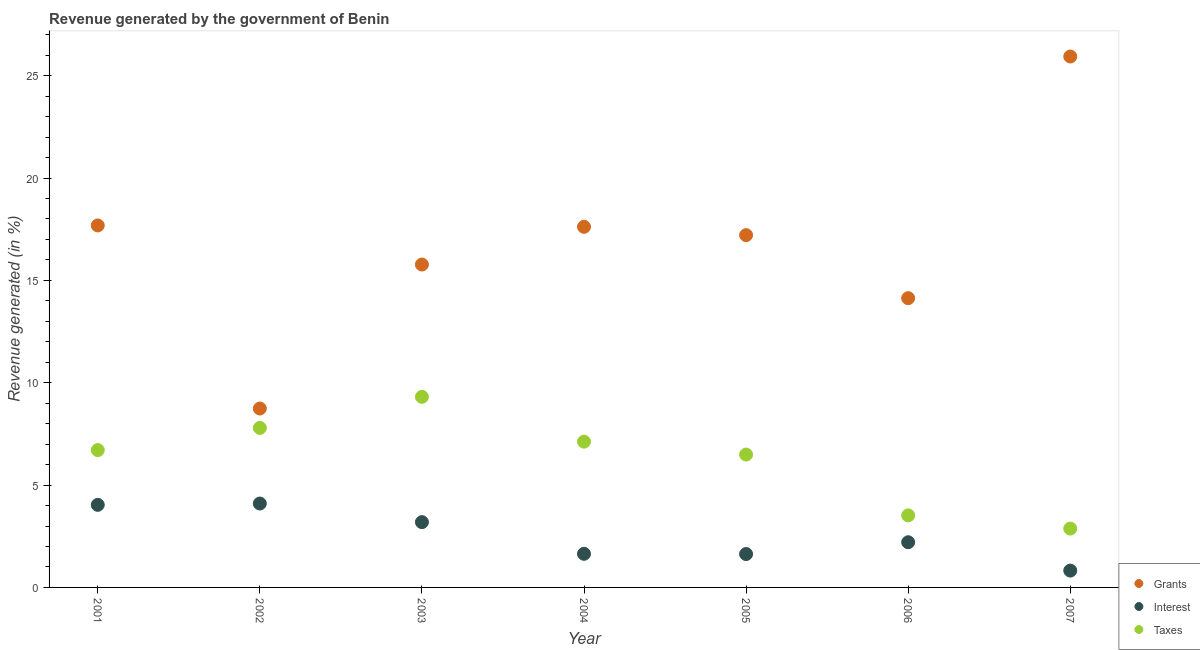How many different coloured dotlines are there?
Make the answer very short. 3. What is the percentage of revenue generated by taxes in 2003?
Ensure brevity in your answer.  9.31. Across all years, what is the maximum percentage of revenue generated by grants?
Offer a very short reply. 25.94. Across all years, what is the minimum percentage of revenue generated by interest?
Provide a succinct answer. 0.82. In which year was the percentage of revenue generated by grants maximum?
Your answer should be compact. 2007. In which year was the percentage of revenue generated by grants minimum?
Provide a succinct answer. 2002. What is the total percentage of revenue generated by taxes in the graph?
Ensure brevity in your answer.  43.82. What is the difference between the percentage of revenue generated by grants in 2002 and that in 2004?
Keep it short and to the point. -8.88. What is the difference between the percentage of revenue generated by taxes in 2004 and the percentage of revenue generated by interest in 2005?
Offer a very short reply. 5.49. What is the average percentage of revenue generated by taxes per year?
Keep it short and to the point. 6.26. In the year 2004, what is the difference between the percentage of revenue generated by taxes and percentage of revenue generated by grants?
Give a very brief answer. -10.5. What is the ratio of the percentage of revenue generated by taxes in 2001 to that in 2005?
Keep it short and to the point. 1.03. Is the difference between the percentage of revenue generated by interest in 2001 and 2006 greater than the difference between the percentage of revenue generated by taxes in 2001 and 2006?
Offer a very short reply. No. What is the difference between the highest and the second highest percentage of revenue generated by interest?
Offer a very short reply. 0.06. What is the difference between the highest and the lowest percentage of revenue generated by interest?
Give a very brief answer. 3.28. Is the percentage of revenue generated by interest strictly less than the percentage of revenue generated by grants over the years?
Ensure brevity in your answer.  Yes. How many dotlines are there?
Make the answer very short. 3. Where does the legend appear in the graph?
Your response must be concise. Bottom right. What is the title of the graph?
Your answer should be compact. Revenue generated by the government of Benin. What is the label or title of the X-axis?
Make the answer very short. Year. What is the label or title of the Y-axis?
Make the answer very short. Revenue generated (in %). What is the Revenue generated (in %) in Grants in 2001?
Offer a very short reply. 17.68. What is the Revenue generated (in %) in Interest in 2001?
Your answer should be very brief. 4.03. What is the Revenue generated (in %) of Taxes in 2001?
Keep it short and to the point. 6.71. What is the Revenue generated (in %) of Grants in 2002?
Ensure brevity in your answer.  8.74. What is the Revenue generated (in %) of Interest in 2002?
Give a very brief answer. 4.1. What is the Revenue generated (in %) in Taxes in 2002?
Offer a very short reply. 7.79. What is the Revenue generated (in %) of Grants in 2003?
Give a very brief answer. 15.77. What is the Revenue generated (in %) of Interest in 2003?
Give a very brief answer. 3.19. What is the Revenue generated (in %) of Taxes in 2003?
Provide a succinct answer. 9.31. What is the Revenue generated (in %) of Grants in 2004?
Give a very brief answer. 17.62. What is the Revenue generated (in %) in Interest in 2004?
Offer a terse response. 1.64. What is the Revenue generated (in %) in Taxes in 2004?
Provide a short and direct response. 7.12. What is the Revenue generated (in %) of Grants in 2005?
Offer a terse response. 17.21. What is the Revenue generated (in %) of Interest in 2005?
Provide a succinct answer. 1.63. What is the Revenue generated (in %) of Taxes in 2005?
Offer a terse response. 6.49. What is the Revenue generated (in %) of Grants in 2006?
Ensure brevity in your answer.  14.13. What is the Revenue generated (in %) of Interest in 2006?
Offer a terse response. 2.21. What is the Revenue generated (in %) in Taxes in 2006?
Make the answer very short. 3.52. What is the Revenue generated (in %) of Grants in 2007?
Ensure brevity in your answer.  25.94. What is the Revenue generated (in %) of Interest in 2007?
Keep it short and to the point. 0.82. What is the Revenue generated (in %) of Taxes in 2007?
Your answer should be compact. 2.88. Across all years, what is the maximum Revenue generated (in %) in Grants?
Give a very brief answer. 25.94. Across all years, what is the maximum Revenue generated (in %) of Interest?
Keep it short and to the point. 4.1. Across all years, what is the maximum Revenue generated (in %) in Taxes?
Give a very brief answer. 9.31. Across all years, what is the minimum Revenue generated (in %) in Grants?
Make the answer very short. 8.74. Across all years, what is the minimum Revenue generated (in %) of Interest?
Provide a short and direct response. 0.82. Across all years, what is the minimum Revenue generated (in %) of Taxes?
Your answer should be very brief. 2.88. What is the total Revenue generated (in %) in Grants in the graph?
Offer a very short reply. 117.09. What is the total Revenue generated (in %) in Interest in the graph?
Provide a short and direct response. 17.62. What is the total Revenue generated (in %) in Taxes in the graph?
Make the answer very short. 43.82. What is the difference between the Revenue generated (in %) of Grants in 2001 and that in 2002?
Offer a very short reply. 8.95. What is the difference between the Revenue generated (in %) of Interest in 2001 and that in 2002?
Provide a short and direct response. -0.06. What is the difference between the Revenue generated (in %) of Taxes in 2001 and that in 2002?
Your response must be concise. -1.08. What is the difference between the Revenue generated (in %) in Grants in 2001 and that in 2003?
Your answer should be compact. 1.91. What is the difference between the Revenue generated (in %) in Interest in 2001 and that in 2003?
Your answer should be compact. 0.84. What is the difference between the Revenue generated (in %) of Taxes in 2001 and that in 2003?
Ensure brevity in your answer.  -2.6. What is the difference between the Revenue generated (in %) in Grants in 2001 and that in 2004?
Provide a short and direct response. 0.07. What is the difference between the Revenue generated (in %) in Interest in 2001 and that in 2004?
Provide a short and direct response. 2.39. What is the difference between the Revenue generated (in %) of Taxes in 2001 and that in 2004?
Keep it short and to the point. -0.41. What is the difference between the Revenue generated (in %) of Grants in 2001 and that in 2005?
Your answer should be very brief. 0.47. What is the difference between the Revenue generated (in %) of Interest in 2001 and that in 2005?
Offer a very short reply. 2.4. What is the difference between the Revenue generated (in %) of Taxes in 2001 and that in 2005?
Provide a succinct answer. 0.22. What is the difference between the Revenue generated (in %) in Grants in 2001 and that in 2006?
Your answer should be very brief. 3.55. What is the difference between the Revenue generated (in %) of Interest in 2001 and that in 2006?
Provide a succinct answer. 1.83. What is the difference between the Revenue generated (in %) in Taxes in 2001 and that in 2006?
Give a very brief answer. 3.19. What is the difference between the Revenue generated (in %) of Grants in 2001 and that in 2007?
Ensure brevity in your answer.  -8.25. What is the difference between the Revenue generated (in %) in Interest in 2001 and that in 2007?
Your answer should be very brief. 3.21. What is the difference between the Revenue generated (in %) in Taxes in 2001 and that in 2007?
Give a very brief answer. 3.83. What is the difference between the Revenue generated (in %) of Grants in 2002 and that in 2003?
Make the answer very short. -7.03. What is the difference between the Revenue generated (in %) in Interest in 2002 and that in 2003?
Your answer should be very brief. 0.91. What is the difference between the Revenue generated (in %) in Taxes in 2002 and that in 2003?
Your response must be concise. -1.52. What is the difference between the Revenue generated (in %) of Grants in 2002 and that in 2004?
Offer a terse response. -8.88. What is the difference between the Revenue generated (in %) of Interest in 2002 and that in 2004?
Provide a succinct answer. 2.46. What is the difference between the Revenue generated (in %) in Taxes in 2002 and that in 2004?
Provide a short and direct response. 0.67. What is the difference between the Revenue generated (in %) of Grants in 2002 and that in 2005?
Offer a terse response. -8.47. What is the difference between the Revenue generated (in %) of Interest in 2002 and that in 2005?
Provide a succinct answer. 2.47. What is the difference between the Revenue generated (in %) in Taxes in 2002 and that in 2005?
Give a very brief answer. 1.3. What is the difference between the Revenue generated (in %) in Grants in 2002 and that in 2006?
Keep it short and to the point. -5.39. What is the difference between the Revenue generated (in %) of Interest in 2002 and that in 2006?
Ensure brevity in your answer.  1.89. What is the difference between the Revenue generated (in %) in Taxes in 2002 and that in 2006?
Ensure brevity in your answer.  4.27. What is the difference between the Revenue generated (in %) of Grants in 2002 and that in 2007?
Ensure brevity in your answer.  -17.2. What is the difference between the Revenue generated (in %) in Interest in 2002 and that in 2007?
Your response must be concise. 3.28. What is the difference between the Revenue generated (in %) in Taxes in 2002 and that in 2007?
Make the answer very short. 4.92. What is the difference between the Revenue generated (in %) of Grants in 2003 and that in 2004?
Give a very brief answer. -1.84. What is the difference between the Revenue generated (in %) of Interest in 2003 and that in 2004?
Make the answer very short. 1.55. What is the difference between the Revenue generated (in %) in Taxes in 2003 and that in 2004?
Your response must be concise. 2.19. What is the difference between the Revenue generated (in %) in Grants in 2003 and that in 2005?
Make the answer very short. -1.44. What is the difference between the Revenue generated (in %) of Interest in 2003 and that in 2005?
Provide a short and direct response. 1.56. What is the difference between the Revenue generated (in %) of Taxes in 2003 and that in 2005?
Your response must be concise. 2.82. What is the difference between the Revenue generated (in %) of Grants in 2003 and that in 2006?
Offer a terse response. 1.64. What is the difference between the Revenue generated (in %) of Interest in 2003 and that in 2006?
Ensure brevity in your answer.  0.98. What is the difference between the Revenue generated (in %) in Taxes in 2003 and that in 2006?
Your answer should be compact. 5.79. What is the difference between the Revenue generated (in %) of Grants in 2003 and that in 2007?
Your response must be concise. -10.16. What is the difference between the Revenue generated (in %) of Interest in 2003 and that in 2007?
Give a very brief answer. 2.37. What is the difference between the Revenue generated (in %) in Taxes in 2003 and that in 2007?
Provide a succinct answer. 6.44. What is the difference between the Revenue generated (in %) in Grants in 2004 and that in 2005?
Give a very brief answer. 0.41. What is the difference between the Revenue generated (in %) in Interest in 2004 and that in 2005?
Keep it short and to the point. 0.01. What is the difference between the Revenue generated (in %) of Taxes in 2004 and that in 2005?
Provide a succinct answer. 0.63. What is the difference between the Revenue generated (in %) in Grants in 2004 and that in 2006?
Offer a very short reply. 3.49. What is the difference between the Revenue generated (in %) of Interest in 2004 and that in 2006?
Keep it short and to the point. -0.56. What is the difference between the Revenue generated (in %) in Taxes in 2004 and that in 2006?
Make the answer very short. 3.6. What is the difference between the Revenue generated (in %) of Grants in 2004 and that in 2007?
Your response must be concise. -8.32. What is the difference between the Revenue generated (in %) of Interest in 2004 and that in 2007?
Provide a succinct answer. 0.82. What is the difference between the Revenue generated (in %) in Taxes in 2004 and that in 2007?
Provide a succinct answer. 4.25. What is the difference between the Revenue generated (in %) in Grants in 2005 and that in 2006?
Ensure brevity in your answer.  3.08. What is the difference between the Revenue generated (in %) of Interest in 2005 and that in 2006?
Ensure brevity in your answer.  -0.58. What is the difference between the Revenue generated (in %) in Taxes in 2005 and that in 2006?
Offer a very short reply. 2.97. What is the difference between the Revenue generated (in %) of Grants in 2005 and that in 2007?
Offer a very short reply. -8.73. What is the difference between the Revenue generated (in %) of Interest in 2005 and that in 2007?
Ensure brevity in your answer.  0.81. What is the difference between the Revenue generated (in %) in Taxes in 2005 and that in 2007?
Provide a succinct answer. 3.62. What is the difference between the Revenue generated (in %) of Grants in 2006 and that in 2007?
Offer a terse response. -11.81. What is the difference between the Revenue generated (in %) of Interest in 2006 and that in 2007?
Give a very brief answer. 1.38. What is the difference between the Revenue generated (in %) of Taxes in 2006 and that in 2007?
Ensure brevity in your answer.  0.64. What is the difference between the Revenue generated (in %) of Grants in 2001 and the Revenue generated (in %) of Interest in 2002?
Your answer should be very brief. 13.59. What is the difference between the Revenue generated (in %) in Grants in 2001 and the Revenue generated (in %) in Taxes in 2002?
Ensure brevity in your answer.  9.89. What is the difference between the Revenue generated (in %) of Interest in 2001 and the Revenue generated (in %) of Taxes in 2002?
Offer a terse response. -3.76. What is the difference between the Revenue generated (in %) in Grants in 2001 and the Revenue generated (in %) in Interest in 2003?
Make the answer very short. 14.49. What is the difference between the Revenue generated (in %) in Grants in 2001 and the Revenue generated (in %) in Taxes in 2003?
Your answer should be very brief. 8.37. What is the difference between the Revenue generated (in %) in Interest in 2001 and the Revenue generated (in %) in Taxes in 2003?
Offer a terse response. -5.28. What is the difference between the Revenue generated (in %) of Grants in 2001 and the Revenue generated (in %) of Interest in 2004?
Keep it short and to the point. 16.04. What is the difference between the Revenue generated (in %) in Grants in 2001 and the Revenue generated (in %) in Taxes in 2004?
Provide a short and direct response. 10.56. What is the difference between the Revenue generated (in %) of Interest in 2001 and the Revenue generated (in %) of Taxes in 2004?
Provide a short and direct response. -3.09. What is the difference between the Revenue generated (in %) of Grants in 2001 and the Revenue generated (in %) of Interest in 2005?
Your answer should be very brief. 16.05. What is the difference between the Revenue generated (in %) in Grants in 2001 and the Revenue generated (in %) in Taxes in 2005?
Make the answer very short. 11.19. What is the difference between the Revenue generated (in %) in Interest in 2001 and the Revenue generated (in %) in Taxes in 2005?
Provide a short and direct response. -2.46. What is the difference between the Revenue generated (in %) in Grants in 2001 and the Revenue generated (in %) in Interest in 2006?
Provide a short and direct response. 15.48. What is the difference between the Revenue generated (in %) in Grants in 2001 and the Revenue generated (in %) in Taxes in 2006?
Offer a terse response. 14.17. What is the difference between the Revenue generated (in %) in Interest in 2001 and the Revenue generated (in %) in Taxes in 2006?
Offer a terse response. 0.51. What is the difference between the Revenue generated (in %) of Grants in 2001 and the Revenue generated (in %) of Interest in 2007?
Make the answer very short. 16.86. What is the difference between the Revenue generated (in %) of Grants in 2001 and the Revenue generated (in %) of Taxes in 2007?
Ensure brevity in your answer.  14.81. What is the difference between the Revenue generated (in %) of Interest in 2001 and the Revenue generated (in %) of Taxes in 2007?
Provide a succinct answer. 1.16. What is the difference between the Revenue generated (in %) in Grants in 2002 and the Revenue generated (in %) in Interest in 2003?
Offer a very short reply. 5.55. What is the difference between the Revenue generated (in %) in Grants in 2002 and the Revenue generated (in %) in Taxes in 2003?
Ensure brevity in your answer.  -0.57. What is the difference between the Revenue generated (in %) of Interest in 2002 and the Revenue generated (in %) of Taxes in 2003?
Give a very brief answer. -5.21. What is the difference between the Revenue generated (in %) in Grants in 2002 and the Revenue generated (in %) in Interest in 2004?
Provide a short and direct response. 7.1. What is the difference between the Revenue generated (in %) of Grants in 2002 and the Revenue generated (in %) of Taxes in 2004?
Your answer should be compact. 1.62. What is the difference between the Revenue generated (in %) of Interest in 2002 and the Revenue generated (in %) of Taxes in 2004?
Make the answer very short. -3.02. What is the difference between the Revenue generated (in %) of Grants in 2002 and the Revenue generated (in %) of Interest in 2005?
Provide a short and direct response. 7.11. What is the difference between the Revenue generated (in %) of Grants in 2002 and the Revenue generated (in %) of Taxes in 2005?
Your answer should be very brief. 2.25. What is the difference between the Revenue generated (in %) in Interest in 2002 and the Revenue generated (in %) in Taxes in 2005?
Keep it short and to the point. -2.39. What is the difference between the Revenue generated (in %) in Grants in 2002 and the Revenue generated (in %) in Interest in 2006?
Give a very brief answer. 6.53. What is the difference between the Revenue generated (in %) in Grants in 2002 and the Revenue generated (in %) in Taxes in 2006?
Ensure brevity in your answer.  5.22. What is the difference between the Revenue generated (in %) in Interest in 2002 and the Revenue generated (in %) in Taxes in 2006?
Provide a succinct answer. 0.58. What is the difference between the Revenue generated (in %) of Grants in 2002 and the Revenue generated (in %) of Interest in 2007?
Give a very brief answer. 7.92. What is the difference between the Revenue generated (in %) in Grants in 2002 and the Revenue generated (in %) in Taxes in 2007?
Keep it short and to the point. 5.86. What is the difference between the Revenue generated (in %) in Interest in 2002 and the Revenue generated (in %) in Taxes in 2007?
Your response must be concise. 1.22. What is the difference between the Revenue generated (in %) in Grants in 2003 and the Revenue generated (in %) in Interest in 2004?
Offer a very short reply. 14.13. What is the difference between the Revenue generated (in %) in Grants in 2003 and the Revenue generated (in %) in Taxes in 2004?
Offer a very short reply. 8.65. What is the difference between the Revenue generated (in %) of Interest in 2003 and the Revenue generated (in %) of Taxes in 2004?
Your answer should be compact. -3.93. What is the difference between the Revenue generated (in %) in Grants in 2003 and the Revenue generated (in %) in Interest in 2005?
Offer a very short reply. 14.14. What is the difference between the Revenue generated (in %) of Grants in 2003 and the Revenue generated (in %) of Taxes in 2005?
Offer a very short reply. 9.28. What is the difference between the Revenue generated (in %) in Interest in 2003 and the Revenue generated (in %) in Taxes in 2005?
Your answer should be compact. -3.3. What is the difference between the Revenue generated (in %) in Grants in 2003 and the Revenue generated (in %) in Interest in 2006?
Ensure brevity in your answer.  13.57. What is the difference between the Revenue generated (in %) of Grants in 2003 and the Revenue generated (in %) of Taxes in 2006?
Keep it short and to the point. 12.25. What is the difference between the Revenue generated (in %) in Interest in 2003 and the Revenue generated (in %) in Taxes in 2006?
Give a very brief answer. -0.33. What is the difference between the Revenue generated (in %) in Grants in 2003 and the Revenue generated (in %) in Interest in 2007?
Make the answer very short. 14.95. What is the difference between the Revenue generated (in %) of Grants in 2003 and the Revenue generated (in %) of Taxes in 2007?
Give a very brief answer. 12.9. What is the difference between the Revenue generated (in %) of Interest in 2003 and the Revenue generated (in %) of Taxes in 2007?
Keep it short and to the point. 0.31. What is the difference between the Revenue generated (in %) of Grants in 2004 and the Revenue generated (in %) of Interest in 2005?
Give a very brief answer. 15.99. What is the difference between the Revenue generated (in %) of Grants in 2004 and the Revenue generated (in %) of Taxes in 2005?
Offer a very short reply. 11.13. What is the difference between the Revenue generated (in %) of Interest in 2004 and the Revenue generated (in %) of Taxes in 2005?
Ensure brevity in your answer.  -4.85. What is the difference between the Revenue generated (in %) of Grants in 2004 and the Revenue generated (in %) of Interest in 2006?
Keep it short and to the point. 15.41. What is the difference between the Revenue generated (in %) in Grants in 2004 and the Revenue generated (in %) in Taxes in 2006?
Give a very brief answer. 14.1. What is the difference between the Revenue generated (in %) in Interest in 2004 and the Revenue generated (in %) in Taxes in 2006?
Your answer should be very brief. -1.88. What is the difference between the Revenue generated (in %) of Grants in 2004 and the Revenue generated (in %) of Interest in 2007?
Provide a succinct answer. 16.79. What is the difference between the Revenue generated (in %) in Grants in 2004 and the Revenue generated (in %) in Taxes in 2007?
Offer a terse response. 14.74. What is the difference between the Revenue generated (in %) of Interest in 2004 and the Revenue generated (in %) of Taxes in 2007?
Your answer should be compact. -1.23. What is the difference between the Revenue generated (in %) of Grants in 2005 and the Revenue generated (in %) of Interest in 2006?
Ensure brevity in your answer.  15. What is the difference between the Revenue generated (in %) in Grants in 2005 and the Revenue generated (in %) in Taxes in 2006?
Provide a succinct answer. 13.69. What is the difference between the Revenue generated (in %) in Interest in 2005 and the Revenue generated (in %) in Taxes in 2006?
Your answer should be compact. -1.89. What is the difference between the Revenue generated (in %) of Grants in 2005 and the Revenue generated (in %) of Interest in 2007?
Keep it short and to the point. 16.39. What is the difference between the Revenue generated (in %) of Grants in 2005 and the Revenue generated (in %) of Taxes in 2007?
Your response must be concise. 14.33. What is the difference between the Revenue generated (in %) of Interest in 2005 and the Revenue generated (in %) of Taxes in 2007?
Provide a short and direct response. -1.25. What is the difference between the Revenue generated (in %) in Grants in 2006 and the Revenue generated (in %) in Interest in 2007?
Provide a short and direct response. 13.31. What is the difference between the Revenue generated (in %) of Grants in 2006 and the Revenue generated (in %) of Taxes in 2007?
Offer a very short reply. 11.25. What is the difference between the Revenue generated (in %) of Interest in 2006 and the Revenue generated (in %) of Taxes in 2007?
Your answer should be compact. -0.67. What is the average Revenue generated (in %) of Grants per year?
Ensure brevity in your answer.  16.73. What is the average Revenue generated (in %) in Interest per year?
Provide a succinct answer. 2.52. What is the average Revenue generated (in %) of Taxes per year?
Provide a short and direct response. 6.26. In the year 2001, what is the difference between the Revenue generated (in %) in Grants and Revenue generated (in %) in Interest?
Make the answer very short. 13.65. In the year 2001, what is the difference between the Revenue generated (in %) in Grants and Revenue generated (in %) in Taxes?
Your answer should be very brief. 10.97. In the year 2001, what is the difference between the Revenue generated (in %) in Interest and Revenue generated (in %) in Taxes?
Your answer should be compact. -2.68. In the year 2002, what is the difference between the Revenue generated (in %) of Grants and Revenue generated (in %) of Interest?
Ensure brevity in your answer.  4.64. In the year 2002, what is the difference between the Revenue generated (in %) of Grants and Revenue generated (in %) of Taxes?
Keep it short and to the point. 0.95. In the year 2002, what is the difference between the Revenue generated (in %) in Interest and Revenue generated (in %) in Taxes?
Keep it short and to the point. -3.69. In the year 2003, what is the difference between the Revenue generated (in %) in Grants and Revenue generated (in %) in Interest?
Give a very brief answer. 12.58. In the year 2003, what is the difference between the Revenue generated (in %) in Grants and Revenue generated (in %) in Taxes?
Keep it short and to the point. 6.46. In the year 2003, what is the difference between the Revenue generated (in %) of Interest and Revenue generated (in %) of Taxes?
Keep it short and to the point. -6.12. In the year 2004, what is the difference between the Revenue generated (in %) of Grants and Revenue generated (in %) of Interest?
Keep it short and to the point. 15.97. In the year 2004, what is the difference between the Revenue generated (in %) in Grants and Revenue generated (in %) in Taxes?
Offer a terse response. 10.5. In the year 2004, what is the difference between the Revenue generated (in %) of Interest and Revenue generated (in %) of Taxes?
Make the answer very short. -5.48. In the year 2005, what is the difference between the Revenue generated (in %) in Grants and Revenue generated (in %) in Interest?
Make the answer very short. 15.58. In the year 2005, what is the difference between the Revenue generated (in %) of Grants and Revenue generated (in %) of Taxes?
Offer a very short reply. 10.72. In the year 2005, what is the difference between the Revenue generated (in %) in Interest and Revenue generated (in %) in Taxes?
Make the answer very short. -4.86. In the year 2006, what is the difference between the Revenue generated (in %) in Grants and Revenue generated (in %) in Interest?
Your answer should be compact. 11.92. In the year 2006, what is the difference between the Revenue generated (in %) in Grants and Revenue generated (in %) in Taxes?
Keep it short and to the point. 10.61. In the year 2006, what is the difference between the Revenue generated (in %) in Interest and Revenue generated (in %) in Taxes?
Your answer should be compact. -1.31. In the year 2007, what is the difference between the Revenue generated (in %) of Grants and Revenue generated (in %) of Interest?
Your answer should be compact. 25.11. In the year 2007, what is the difference between the Revenue generated (in %) of Grants and Revenue generated (in %) of Taxes?
Your response must be concise. 23.06. In the year 2007, what is the difference between the Revenue generated (in %) of Interest and Revenue generated (in %) of Taxes?
Give a very brief answer. -2.05. What is the ratio of the Revenue generated (in %) in Grants in 2001 to that in 2002?
Your answer should be compact. 2.02. What is the ratio of the Revenue generated (in %) of Interest in 2001 to that in 2002?
Offer a terse response. 0.98. What is the ratio of the Revenue generated (in %) in Taxes in 2001 to that in 2002?
Ensure brevity in your answer.  0.86. What is the ratio of the Revenue generated (in %) of Grants in 2001 to that in 2003?
Your response must be concise. 1.12. What is the ratio of the Revenue generated (in %) in Interest in 2001 to that in 2003?
Keep it short and to the point. 1.26. What is the ratio of the Revenue generated (in %) in Taxes in 2001 to that in 2003?
Ensure brevity in your answer.  0.72. What is the ratio of the Revenue generated (in %) in Interest in 2001 to that in 2004?
Offer a very short reply. 2.46. What is the ratio of the Revenue generated (in %) of Taxes in 2001 to that in 2004?
Your answer should be very brief. 0.94. What is the ratio of the Revenue generated (in %) of Grants in 2001 to that in 2005?
Make the answer very short. 1.03. What is the ratio of the Revenue generated (in %) in Interest in 2001 to that in 2005?
Give a very brief answer. 2.47. What is the ratio of the Revenue generated (in %) in Taxes in 2001 to that in 2005?
Keep it short and to the point. 1.03. What is the ratio of the Revenue generated (in %) of Grants in 2001 to that in 2006?
Provide a succinct answer. 1.25. What is the ratio of the Revenue generated (in %) of Interest in 2001 to that in 2006?
Make the answer very short. 1.83. What is the ratio of the Revenue generated (in %) of Taxes in 2001 to that in 2006?
Give a very brief answer. 1.91. What is the ratio of the Revenue generated (in %) in Grants in 2001 to that in 2007?
Give a very brief answer. 0.68. What is the ratio of the Revenue generated (in %) in Interest in 2001 to that in 2007?
Ensure brevity in your answer.  4.91. What is the ratio of the Revenue generated (in %) of Taxes in 2001 to that in 2007?
Your response must be concise. 2.33. What is the ratio of the Revenue generated (in %) in Grants in 2002 to that in 2003?
Provide a short and direct response. 0.55. What is the ratio of the Revenue generated (in %) in Interest in 2002 to that in 2003?
Keep it short and to the point. 1.29. What is the ratio of the Revenue generated (in %) of Taxes in 2002 to that in 2003?
Keep it short and to the point. 0.84. What is the ratio of the Revenue generated (in %) of Grants in 2002 to that in 2004?
Your response must be concise. 0.5. What is the ratio of the Revenue generated (in %) in Interest in 2002 to that in 2004?
Provide a short and direct response. 2.5. What is the ratio of the Revenue generated (in %) in Taxes in 2002 to that in 2004?
Offer a terse response. 1.09. What is the ratio of the Revenue generated (in %) in Grants in 2002 to that in 2005?
Provide a succinct answer. 0.51. What is the ratio of the Revenue generated (in %) of Interest in 2002 to that in 2005?
Your answer should be very brief. 2.51. What is the ratio of the Revenue generated (in %) of Taxes in 2002 to that in 2005?
Ensure brevity in your answer.  1.2. What is the ratio of the Revenue generated (in %) in Grants in 2002 to that in 2006?
Your response must be concise. 0.62. What is the ratio of the Revenue generated (in %) in Interest in 2002 to that in 2006?
Make the answer very short. 1.86. What is the ratio of the Revenue generated (in %) in Taxes in 2002 to that in 2006?
Ensure brevity in your answer.  2.21. What is the ratio of the Revenue generated (in %) of Grants in 2002 to that in 2007?
Your answer should be compact. 0.34. What is the ratio of the Revenue generated (in %) in Interest in 2002 to that in 2007?
Your answer should be very brief. 4.98. What is the ratio of the Revenue generated (in %) in Taxes in 2002 to that in 2007?
Provide a succinct answer. 2.71. What is the ratio of the Revenue generated (in %) in Grants in 2003 to that in 2004?
Provide a succinct answer. 0.9. What is the ratio of the Revenue generated (in %) of Interest in 2003 to that in 2004?
Offer a terse response. 1.94. What is the ratio of the Revenue generated (in %) in Taxes in 2003 to that in 2004?
Give a very brief answer. 1.31. What is the ratio of the Revenue generated (in %) of Grants in 2003 to that in 2005?
Provide a short and direct response. 0.92. What is the ratio of the Revenue generated (in %) of Interest in 2003 to that in 2005?
Offer a terse response. 1.96. What is the ratio of the Revenue generated (in %) of Taxes in 2003 to that in 2005?
Give a very brief answer. 1.43. What is the ratio of the Revenue generated (in %) of Grants in 2003 to that in 2006?
Provide a short and direct response. 1.12. What is the ratio of the Revenue generated (in %) of Interest in 2003 to that in 2006?
Offer a terse response. 1.45. What is the ratio of the Revenue generated (in %) in Taxes in 2003 to that in 2006?
Provide a succinct answer. 2.65. What is the ratio of the Revenue generated (in %) of Grants in 2003 to that in 2007?
Give a very brief answer. 0.61. What is the ratio of the Revenue generated (in %) of Interest in 2003 to that in 2007?
Your response must be concise. 3.88. What is the ratio of the Revenue generated (in %) of Taxes in 2003 to that in 2007?
Ensure brevity in your answer.  3.24. What is the ratio of the Revenue generated (in %) of Grants in 2004 to that in 2005?
Your answer should be compact. 1.02. What is the ratio of the Revenue generated (in %) of Interest in 2004 to that in 2005?
Ensure brevity in your answer.  1.01. What is the ratio of the Revenue generated (in %) of Taxes in 2004 to that in 2005?
Ensure brevity in your answer.  1.1. What is the ratio of the Revenue generated (in %) of Grants in 2004 to that in 2006?
Make the answer very short. 1.25. What is the ratio of the Revenue generated (in %) of Interest in 2004 to that in 2006?
Make the answer very short. 0.74. What is the ratio of the Revenue generated (in %) of Taxes in 2004 to that in 2006?
Offer a very short reply. 2.02. What is the ratio of the Revenue generated (in %) of Grants in 2004 to that in 2007?
Provide a succinct answer. 0.68. What is the ratio of the Revenue generated (in %) in Interest in 2004 to that in 2007?
Ensure brevity in your answer.  2. What is the ratio of the Revenue generated (in %) of Taxes in 2004 to that in 2007?
Offer a terse response. 2.48. What is the ratio of the Revenue generated (in %) in Grants in 2005 to that in 2006?
Your answer should be compact. 1.22. What is the ratio of the Revenue generated (in %) of Interest in 2005 to that in 2006?
Ensure brevity in your answer.  0.74. What is the ratio of the Revenue generated (in %) in Taxes in 2005 to that in 2006?
Provide a short and direct response. 1.84. What is the ratio of the Revenue generated (in %) in Grants in 2005 to that in 2007?
Ensure brevity in your answer.  0.66. What is the ratio of the Revenue generated (in %) of Interest in 2005 to that in 2007?
Offer a terse response. 1.98. What is the ratio of the Revenue generated (in %) in Taxes in 2005 to that in 2007?
Your answer should be compact. 2.26. What is the ratio of the Revenue generated (in %) in Grants in 2006 to that in 2007?
Provide a succinct answer. 0.54. What is the ratio of the Revenue generated (in %) in Interest in 2006 to that in 2007?
Your answer should be very brief. 2.68. What is the ratio of the Revenue generated (in %) of Taxes in 2006 to that in 2007?
Provide a succinct answer. 1.22. What is the difference between the highest and the second highest Revenue generated (in %) in Grants?
Provide a short and direct response. 8.25. What is the difference between the highest and the second highest Revenue generated (in %) of Interest?
Provide a succinct answer. 0.06. What is the difference between the highest and the second highest Revenue generated (in %) in Taxes?
Give a very brief answer. 1.52. What is the difference between the highest and the lowest Revenue generated (in %) in Grants?
Ensure brevity in your answer.  17.2. What is the difference between the highest and the lowest Revenue generated (in %) in Interest?
Keep it short and to the point. 3.28. What is the difference between the highest and the lowest Revenue generated (in %) of Taxes?
Your answer should be very brief. 6.44. 